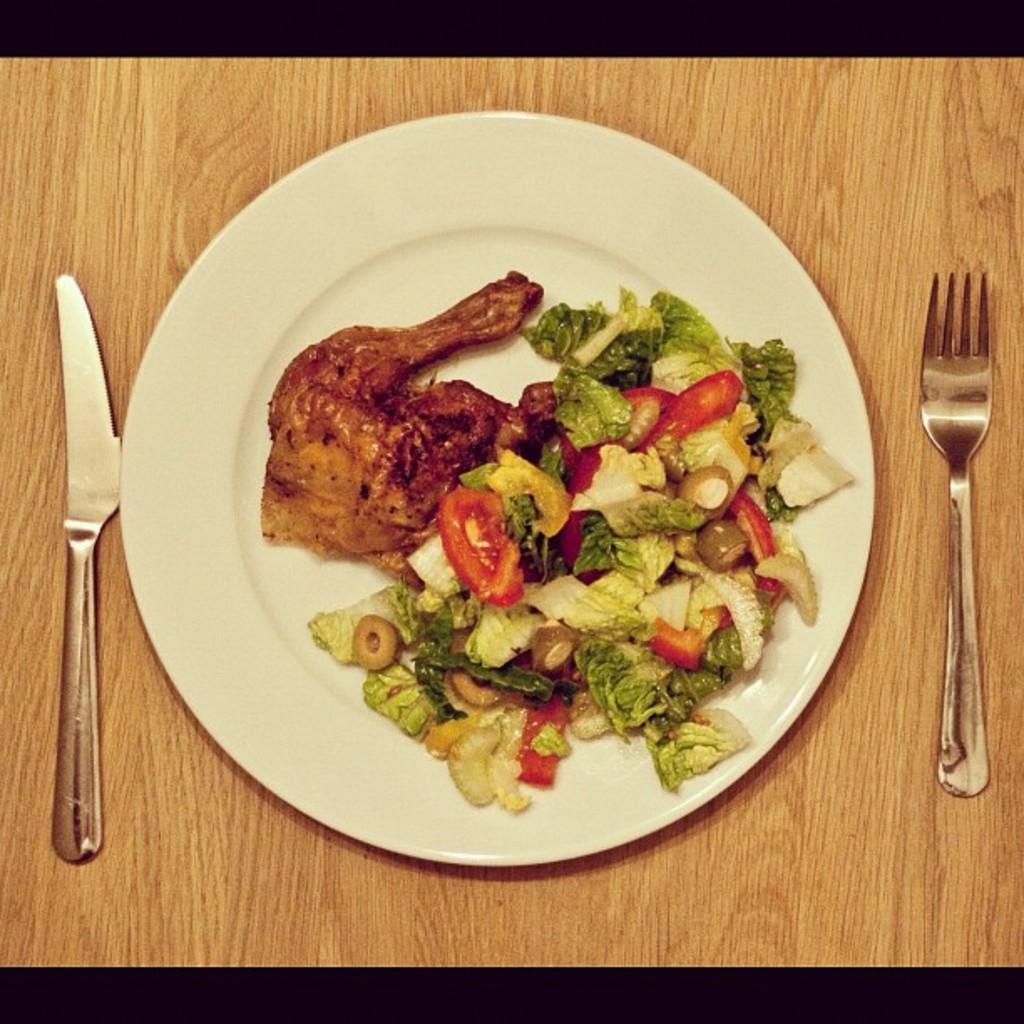Could you give a brief overview of what you see in this image? In this image I see brown color surface on which there is a white plate and I see food on it and I see that the food is of brown, green, yellow, white and green in color and I see a knife and a fork beside to the plate. 